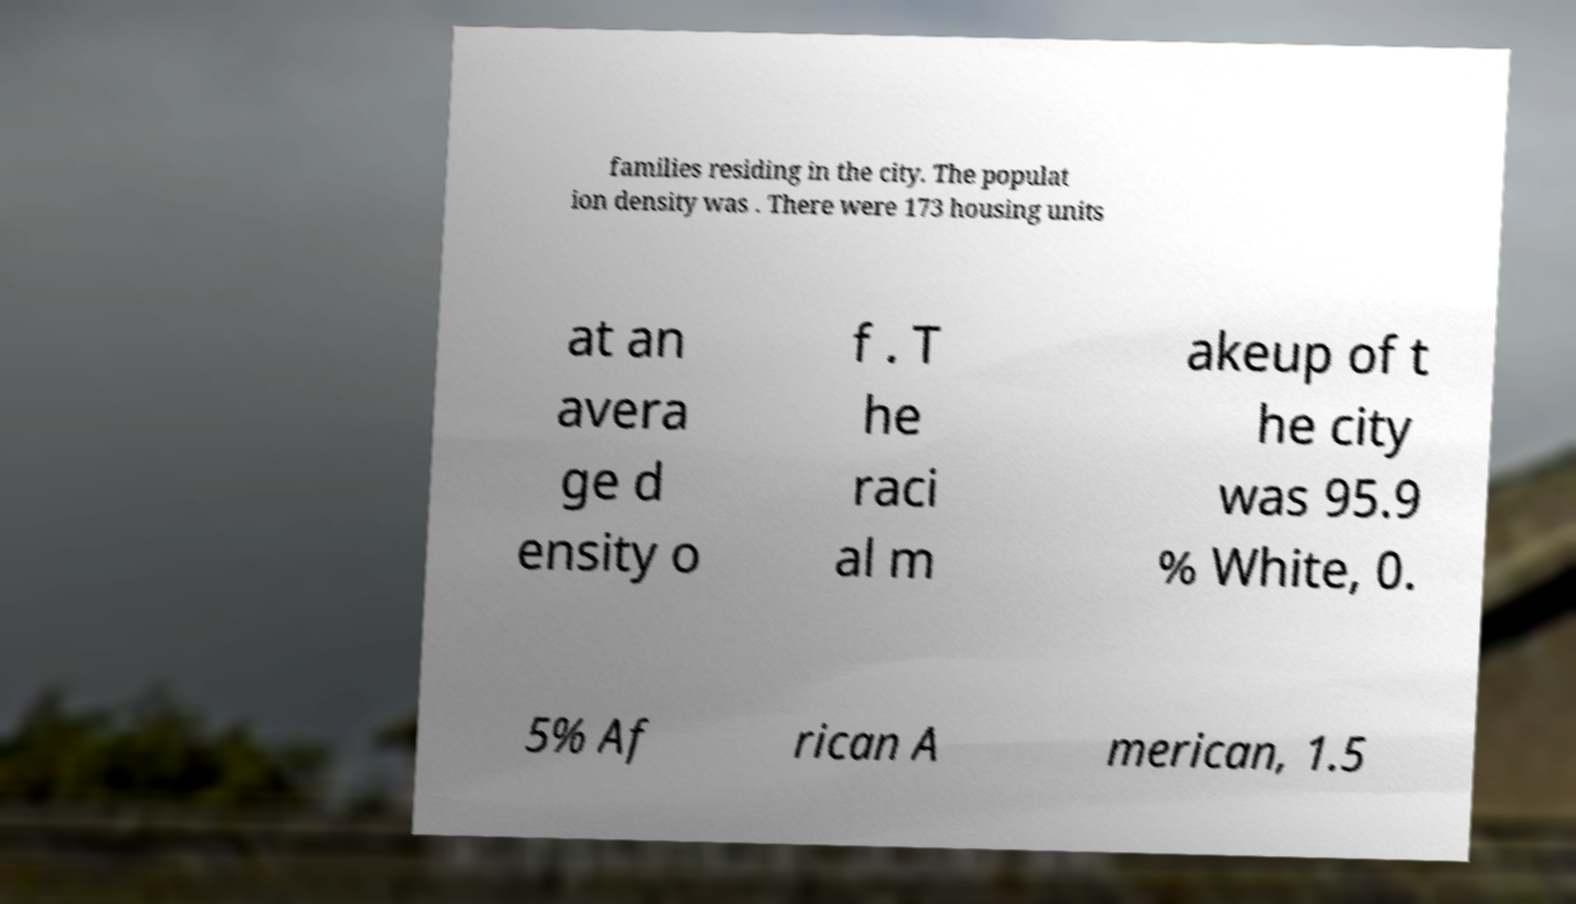Can you read and provide the text displayed in the image?This photo seems to have some interesting text. Can you extract and type it out for me? families residing in the city. The populat ion density was . There were 173 housing units at an avera ge d ensity o f . T he raci al m akeup of t he city was 95.9 % White, 0. 5% Af rican A merican, 1.5 